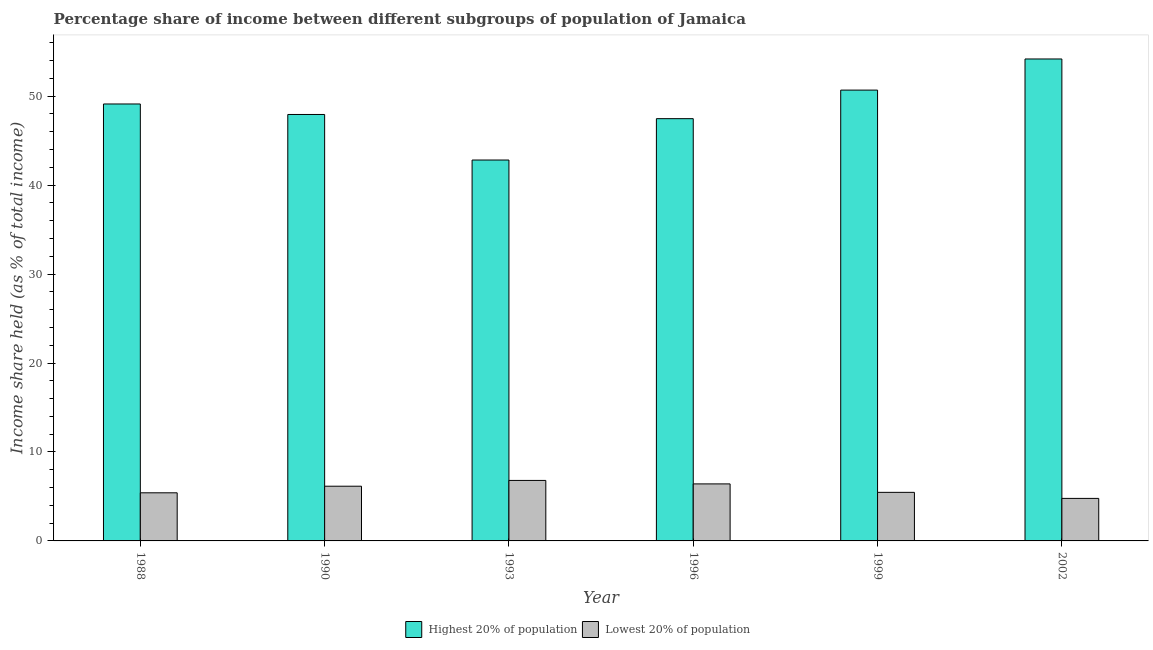How many different coloured bars are there?
Your answer should be very brief. 2. How many bars are there on the 2nd tick from the right?
Your answer should be compact. 2. In how many cases, is the number of bars for a given year not equal to the number of legend labels?
Provide a succinct answer. 0. What is the income share held by lowest 20% of the population in 1990?
Provide a short and direct response. 6.15. Across all years, what is the maximum income share held by highest 20% of the population?
Ensure brevity in your answer.  54.18. Across all years, what is the minimum income share held by lowest 20% of the population?
Provide a short and direct response. 4.78. In which year was the income share held by lowest 20% of the population maximum?
Your answer should be compact. 1993. What is the total income share held by highest 20% of the population in the graph?
Your response must be concise. 292.21. What is the difference between the income share held by lowest 20% of the population in 1996 and that in 1999?
Make the answer very short. 0.95. What is the difference between the income share held by highest 20% of the population in 1990 and the income share held by lowest 20% of the population in 1988?
Offer a very short reply. -1.18. What is the average income share held by lowest 20% of the population per year?
Make the answer very short. 5.83. In the year 2002, what is the difference between the income share held by highest 20% of the population and income share held by lowest 20% of the population?
Your response must be concise. 0. What is the ratio of the income share held by highest 20% of the population in 1988 to that in 1999?
Your answer should be compact. 0.97. What is the difference between the highest and the second highest income share held by lowest 20% of the population?
Ensure brevity in your answer.  0.39. What is the difference between the highest and the lowest income share held by highest 20% of the population?
Provide a succinct answer. 11.36. What does the 1st bar from the left in 1988 represents?
Your response must be concise. Highest 20% of population. What does the 2nd bar from the right in 1999 represents?
Give a very brief answer. Highest 20% of population. How many bars are there?
Give a very brief answer. 12. What is the difference between two consecutive major ticks on the Y-axis?
Offer a terse response. 10. Does the graph contain any zero values?
Make the answer very short. No. Where does the legend appear in the graph?
Your answer should be very brief. Bottom center. How many legend labels are there?
Provide a succinct answer. 2. How are the legend labels stacked?
Provide a short and direct response. Horizontal. What is the title of the graph?
Ensure brevity in your answer.  Percentage share of income between different subgroups of population of Jamaica. Does "All education staff compensation" appear as one of the legend labels in the graph?
Your answer should be very brief. No. What is the label or title of the X-axis?
Provide a succinct answer. Year. What is the label or title of the Y-axis?
Keep it short and to the point. Income share held (as % of total income). What is the Income share held (as % of total income) of Highest 20% of population in 1988?
Provide a succinct answer. 49.12. What is the Income share held (as % of total income) in Lowest 20% of population in 1988?
Offer a very short reply. 5.41. What is the Income share held (as % of total income) of Highest 20% of population in 1990?
Offer a terse response. 47.94. What is the Income share held (as % of total income) of Lowest 20% of population in 1990?
Your response must be concise. 6.15. What is the Income share held (as % of total income) in Highest 20% of population in 1993?
Provide a short and direct response. 42.82. What is the Income share held (as % of total income) of Lowest 20% of population in 1993?
Your answer should be very brief. 6.8. What is the Income share held (as % of total income) in Highest 20% of population in 1996?
Provide a succinct answer. 47.47. What is the Income share held (as % of total income) of Lowest 20% of population in 1996?
Provide a short and direct response. 6.41. What is the Income share held (as % of total income) in Highest 20% of population in 1999?
Ensure brevity in your answer.  50.68. What is the Income share held (as % of total income) of Lowest 20% of population in 1999?
Keep it short and to the point. 5.46. What is the Income share held (as % of total income) in Highest 20% of population in 2002?
Provide a succinct answer. 54.18. What is the Income share held (as % of total income) of Lowest 20% of population in 2002?
Make the answer very short. 4.78. Across all years, what is the maximum Income share held (as % of total income) in Highest 20% of population?
Keep it short and to the point. 54.18. Across all years, what is the maximum Income share held (as % of total income) of Lowest 20% of population?
Your answer should be very brief. 6.8. Across all years, what is the minimum Income share held (as % of total income) in Highest 20% of population?
Your answer should be very brief. 42.82. Across all years, what is the minimum Income share held (as % of total income) in Lowest 20% of population?
Your answer should be very brief. 4.78. What is the total Income share held (as % of total income) in Highest 20% of population in the graph?
Make the answer very short. 292.21. What is the total Income share held (as % of total income) of Lowest 20% of population in the graph?
Your answer should be very brief. 35.01. What is the difference between the Income share held (as % of total income) of Highest 20% of population in 1988 and that in 1990?
Your answer should be very brief. 1.18. What is the difference between the Income share held (as % of total income) of Lowest 20% of population in 1988 and that in 1990?
Provide a short and direct response. -0.74. What is the difference between the Income share held (as % of total income) of Highest 20% of population in 1988 and that in 1993?
Your answer should be compact. 6.3. What is the difference between the Income share held (as % of total income) of Lowest 20% of population in 1988 and that in 1993?
Your answer should be very brief. -1.39. What is the difference between the Income share held (as % of total income) of Highest 20% of population in 1988 and that in 1996?
Offer a very short reply. 1.65. What is the difference between the Income share held (as % of total income) of Lowest 20% of population in 1988 and that in 1996?
Keep it short and to the point. -1. What is the difference between the Income share held (as % of total income) in Highest 20% of population in 1988 and that in 1999?
Give a very brief answer. -1.56. What is the difference between the Income share held (as % of total income) in Highest 20% of population in 1988 and that in 2002?
Offer a very short reply. -5.06. What is the difference between the Income share held (as % of total income) of Lowest 20% of population in 1988 and that in 2002?
Your response must be concise. 0.63. What is the difference between the Income share held (as % of total income) in Highest 20% of population in 1990 and that in 1993?
Your response must be concise. 5.12. What is the difference between the Income share held (as % of total income) in Lowest 20% of population in 1990 and that in 1993?
Provide a succinct answer. -0.65. What is the difference between the Income share held (as % of total income) in Highest 20% of population in 1990 and that in 1996?
Keep it short and to the point. 0.47. What is the difference between the Income share held (as % of total income) of Lowest 20% of population in 1990 and that in 1996?
Your response must be concise. -0.26. What is the difference between the Income share held (as % of total income) of Highest 20% of population in 1990 and that in 1999?
Provide a succinct answer. -2.74. What is the difference between the Income share held (as % of total income) of Lowest 20% of population in 1990 and that in 1999?
Your answer should be very brief. 0.69. What is the difference between the Income share held (as % of total income) of Highest 20% of population in 1990 and that in 2002?
Your answer should be very brief. -6.24. What is the difference between the Income share held (as % of total income) of Lowest 20% of population in 1990 and that in 2002?
Provide a succinct answer. 1.37. What is the difference between the Income share held (as % of total income) of Highest 20% of population in 1993 and that in 1996?
Provide a succinct answer. -4.65. What is the difference between the Income share held (as % of total income) in Lowest 20% of population in 1993 and that in 1996?
Make the answer very short. 0.39. What is the difference between the Income share held (as % of total income) in Highest 20% of population in 1993 and that in 1999?
Your answer should be very brief. -7.86. What is the difference between the Income share held (as % of total income) in Lowest 20% of population in 1993 and that in 1999?
Provide a succinct answer. 1.34. What is the difference between the Income share held (as % of total income) in Highest 20% of population in 1993 and that in 2002?
Your answer should be compact. -11.36. What is the difference between the Income share held (as % of total income) of Lowest 20% of population in 1993 and that in 2002?
Your response must be concise. 2.02. What is the difference between the Income share held (as % of total income) of Highest 20% of population in 1996 and that in 1999?
Make the answer very short. -3.21. What is the difference between the Income share held (as % of total income) in Lowest 20% of population in 1996 and that in 1999?
Provide a short and direct response. 0.95. What is the difference between the Income share held (as % of total income) in Highest 20% of population in 1996 and that in 2002?
Keep it short and to the point. -6.71. What is the difference between the Income share held (as % of total income) in Lowest 20% of population in 1996 and that in 2002?
Give a very brief answer. 1.63. What is the difference between the Income share held (as % of total income) of Lowest 20% of population in 1999 and that in 2002?
Your answer should be very brief. 0.68. What is the difference between the Income share held (as % of total income) in Highest 20% of population in 1988 and the Income share held (as % of total income) in Lowest 20% of population in 1990?
Your response must be concise. 42.97. What is the difference between the Income share held (as % of total income) in Highest 20% of population in 1988 and the Income share held (as % of total income) in Lowest 20% of population in 1993?
Ensure brevity in your answer.  42.32. What is the difference between the Income share held (as % of total income) in Highest 20% of population in 1988 and the Income share held (as % of total income) in Lowest 20% of population in 1996?
Offer a terse response. 42.71. What is the difference between the Income share held (as % of total income) of Highest 20% of population in 1988 and the Income share held (as % of total income) of Lowest 20% of population in 1999?
Your answer should be compact. 43.66. What is the difference between the Income share held (as % of total income) in Highest 20% of population in 1988 and the Income share held (as % of total income) in Lowest 20% of population in 2002?
Offer a terse response. 44.34. What is the difference between the Income share held (as % of total income) of Highest 20% of population in 1990 and the Income share held (as % of total income) of Lowest 20% of population in 1993?
Your answer should be compact. 41.14. What is the difference between the Income share held (as % of total income) in Highest 20% of population in 1990 and the Income share held (as % of total income) in Lowest 20% of population in 1996?
Your response must be concise. 41.53. What is the difference between the Income share held (as % of total income) in Highest 20% of population in 1990 and the Income share held (as % of total income) in Lowest 20% of population in 1999?
Provide a succinct answer. 42.48. What is the difference between the Income share held (as % of total income) in Highest 20% of population in 1990 and the Income share held (as % of total income) in Lowest 20% of population in 2002?
Provide a short and direct response. 43.16. What is the difference between the Income share held (as % of total income) of Highest 20% of population in 1993 and the Income share held (as % of total income) of Lowest 20% of population in 1996?
Offer a terse response. 36.41. What is the difference between the Income share held (as % of total income) in Highest 20% of population in 1993 and the Income share held (as % of total income) in Lowest 20% of population in 1999?
Your answer should be compact. 37.36. What is the difference between the Income share held (as % of total income) of Highest 20% of population in 1993 and the Income share held (as % of total income) of Lowest 20% of population in 2002?
Make the answer very short. 38.04. What is the difference between the Income share held (as % of total income) of Highest 20% of population in 1996 and the Income share held (as % of total income) of Lowest 20% of population in 1999?
Ensure brevity in your answer.  42.01. What is the difference between the Income share held (as % of total income) in Highest 20% of population in 1996 and the Income share held (as % of total income) in Lowest 20% of population in 2002?
Your response must be concise. 42.69. What is the difference between the Income share held (as % of total income) of Highest 20% of population in 1999 and the Income share held (as % of total income) of Lowest 20% of population in 2002?
Keep it short and to the point. 45.9. What is the average Income share held (as % of total income) of Highest 20% of population per year?
Make the answer very short. 48.7. What is the average Income share held (as % of total income) in Lowest 20% of population per year?
Make the answer very short. 5.83. In the year 1988, what is the difference between the Income share held (as % of total income) in Highest 20% of population and Income share held (as % of total income) in Lowest 20% of population?
Your response must be concise. 43.71. In the year 1990, what is the difference between the Income share held (as % of total income) of Highest 20% of population and Income share held (as % of total income) of Lowest 20% of population?
Your response must be concise. 41.79. In the year 1993, what is the difference between the Income share held (as % of total income) of Highest 20% of population and Income share held (as % of total income) of Lowest 20% of population?
Provide a succinct answer. 36.02. In the year 1996, what is the difference between the Income share held (as % of total income) of Highest 20% of population and Income share held (as % of total income) of Lowest 20% of population?
Ensure brevity in your answer.  41.06. In the year 1999, what is the difference between the Income share held (as % of total income) in Highest 20% of population and Income share held (as % of total income) in Lowest 20% of population?
Your response must be concise. 45.22. In the year 2002, what is the difference between the Income share held (as % of total income) in Highest 20% of population and Income share held (as % of total income) in Lowest 20% of population?
Your answer should be very brief. 49.4. What is the ratio of the Income share held (as % of total income) in Highest 20% of population in 1988 to that in 1990?
Your answer should be very brief. 1.02. What is the ratio of the Income share held (as % of total income) in Lowest 20% of population in 1988 to that in 1990?
Your answer should be very brief. 0.88. What is the ratio of the Income share held (as % of total income) in Highest 20% of population in 1988 to that in 1993?
Offer a very short reply. 1.15. What is the ratio of the Income share held (as % of total income) in Lowest 20% of population in 1988 to that in 1993?
Offer a terse response. 0.8. What is the ratio of the Income share held (as % of total income) in Highest 20% of population in 1988 to that in 1996?
Make the answer very short. 1.03. What is the ratio of the Income share held (as % of total income) of Lowest 20% of population in 1988 to that in 1996?
Provide a succinct answer. 0.84. What is the ratio of the Income share held (as % of total income) in Highest 20% of population in 1988 to that in 1999?
Offer a very short reply. 0.97. What is the ratio of the Income share held (as % of total income) of Highest 20% of population in 1988 to that in 2002?
Offer a terse response. 0.91. What is the ratio of the Income share held (as % of total income) of Lowest 20% of population in 1988 to that in 2002?
Offer a very short reply. 1.13. What is the ratio of the Income share held (as % of total income) in Highest 20% of population in 1990 to that in 1993?
Provide a short and direct response. 1.12. What is the ratio of the Income share held (as % of total income) of Lowest 20% of population in 1990 to that in 1993?
Your answer should be very brief. 0.9. What is the ratio of the Income share held (as % of total income) in Highest 20% of population in 1990 to that in 1996?
Give a very brief answer. 1.01. What is the ratio of the Income share held (as % of total income) in Lowest 20% of population in 1990 to that in 1996?
Keep it short and to the point. 0.96. What is the ratio of the Income share held (as % of total income) of Highest 20% of population in 1990 to that in 1999?
Make the answer very short. 0.95. What is the ratio of the Income share held (as % of total income) in Lowest 20% of population in 1990 to that in 1999?
Your response must be concise. 1.13. What is the ratio of the Income share held (as % of total income) of Highest 20% of population in 1990 to that in 2002?
Provide a succinct answer. 0.88. What is the ratio of the Income share held (as % of total income) of Lowest 20% of population in 1990 to that in 2002?
Give a very brief answer. 1.29. What is the ratio of the Income share held (as % of total income) in Highest 20% of population in 1993 to that in 1996?
Ensure brevity in your answer.  0.9. What is the ratio of the Income share held (as % of total income) in Lowest 20% of population in 1993 to that in 1996?
Ensure brevity in your answer.  1.06. What is the ratio of the Income share held (as % of total income) in Highest 20% of population in 1993 to that in 1999?
Ensure brevity in your answer.  0.84. What is the ratio of the Income share held (as % of total income) in Lowest 20% of population in 1993 to that in 1999?
Offer a very short reply. 1.25. What is the ratio of the Income share held (as % of total income) in Highest 20% of population in 1993 to that in 2002?
Provide a short and direct response. 0.79. What is the ratio of the Income share held (as % of total income) in Lowest 20% of population in 1993 to that in 2002?
Provide a short and direct response. 1.42. What is the ratio of the Income share held (as % of total income) of Highest 20% of population in 1996 to that in 1999?
Ensure brevity in your answer.  0.94. What is the ratio of the Income share held (as % of total income) in Lowest 20% of population in 1996 to that in 1999?
Provide a succinct answer. 1.17. What is the ratio of the Income share held (as % of total income) of Highest 20% of population in 1996 to that in 2002?
Your answer should be compact. 0.88. What is the ratio of the Income share held (as % of total income) in Lowest 20% of population in 1996 to that in 2002?
Provide a short and direct response. 1.34. What is the ratio of the Income share held (as % of total income) in Highest 20% of population in 1999 to that in 2002?
Your answer should be very brief. 0.94. What is the ratio of the Income share held (as % of total income) in Lowest 20% of population in 1999 to that in 2002?
Offer a very short reply. 1.14. What is the difference between the highest and the second highest Income share held (as % of total income) of Highest 20% of population?
Your answer should be very brief. 3.5. What is the difference between the highest and the second highest Income share held (as % of total income) of Lowest 20% of population?
Provide a succinct answer. 0.39. What is the difference between the highest and the lowest Income share held (as % of total income) of Highest 20% of population?
Provide a succinct answer. 11.36. What is the difference between the highest and the lowest Income share held (as % of total income) in Lowest 20% of population?
Provide a short and direct response. 2.02. 